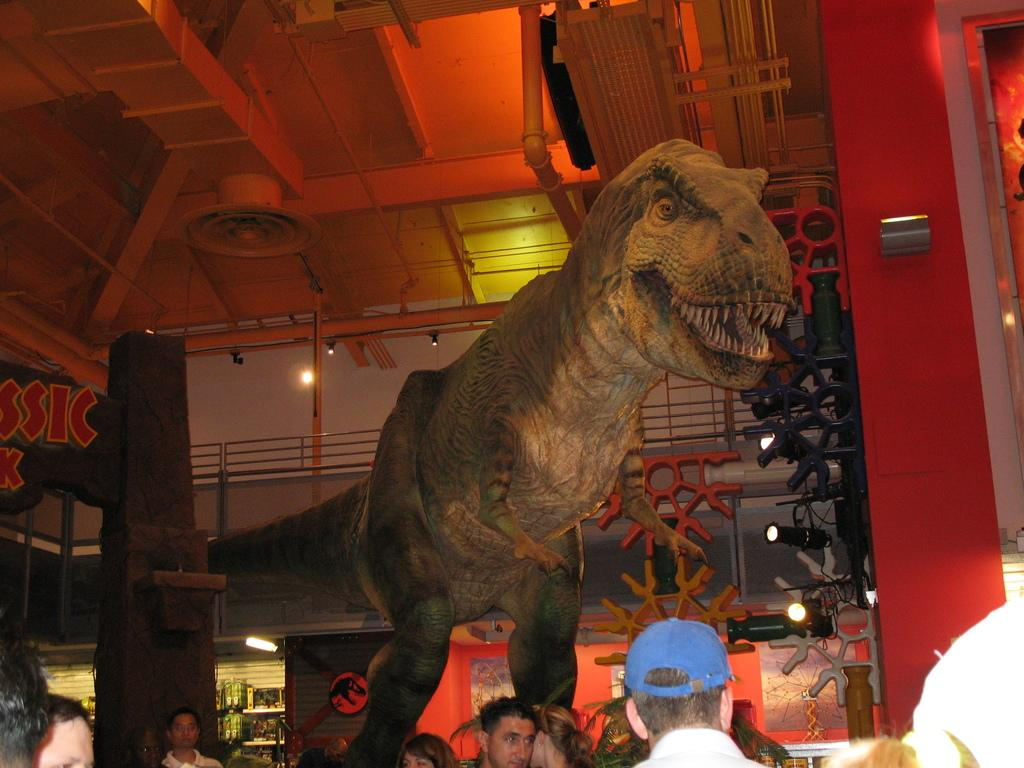What is the main subject of the image? There is a statue of a dinosaur in the image. Are there any people in the image? Yes, there is a group of people in the image. What can be seen illuminating the scene? There are focus lights in the image. What type of architectural feature is present in the image? There are iron grilles in the image. What other object can be seen in the image? There is a pipe in the image. Can you describe any other objects present in the image? There are other objects present in the image, but their specific details are not mentioned in the provided facts. What type of song is being sung by the clover in the image? There is no clover present in the image, and therefore no such activity can be observed. 